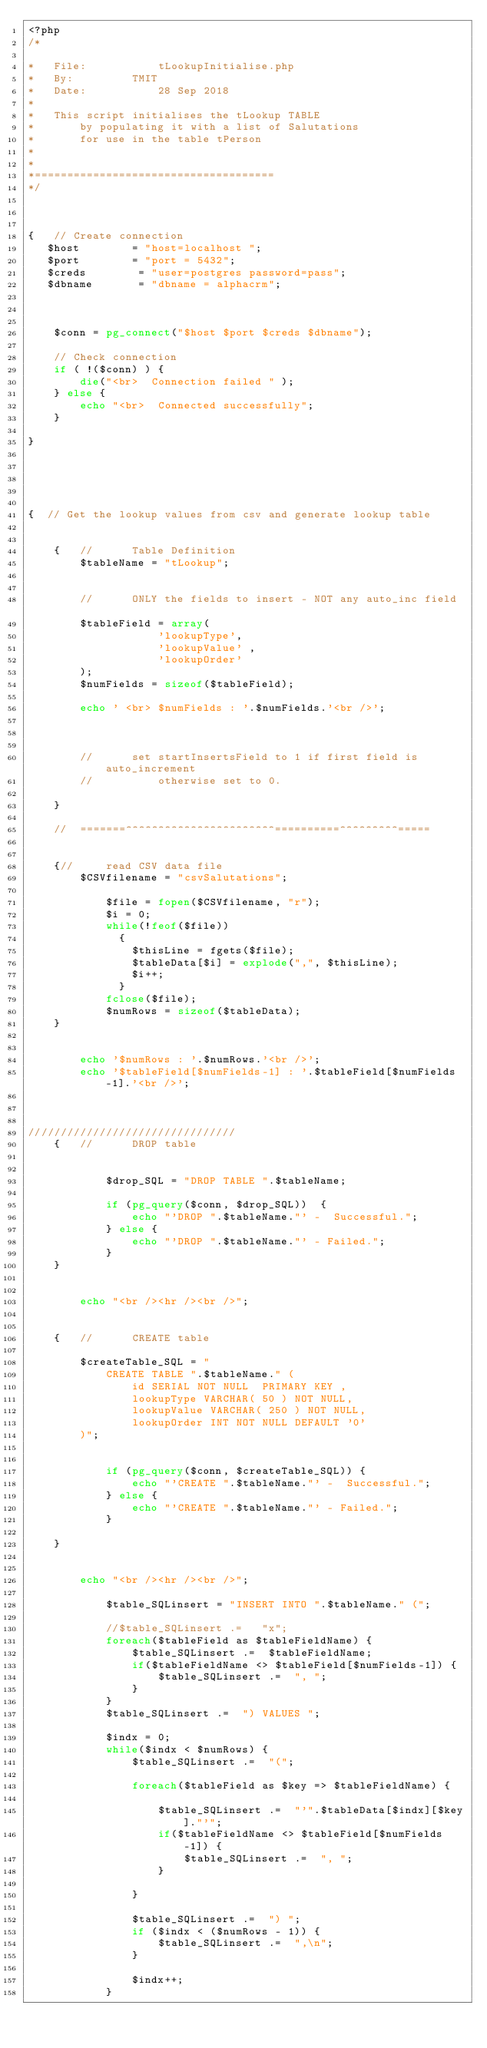<code> <loc_0><loc_0><loc_500><loc_500><_PHP_><?php
/*

*	File:			tLookupInitialise.php
*	By:			TMIT
*	Date:			28 Sep 2018
*
*	This script initialises the tLookup TABLE
*		by populating it with a list of Salutations
*		for use in the table tPerson
*
*
*=====================================
*/



{	// Create connection
   $host        = "host=localhost ";
   $port        = "port = 5432";
   $creds 		 = "user=postgres password=pass";
   $dbname 		 = "dbname = alphacrm";



	$conn = pg_connect("$host $port $creds $dbname");
	
	// Check connection
	if ( !($conn) ) {
	    die("<br>  Connection failed " );
	} else {
		echo "<br>  Connected successfully";
	}
	
}





{  // Get the lookup values from csv and generate lookup table

	
	{	//		Table Definition 
		$tableName = "tLookup";	


		//		ONLY the fields to insert - NOT any auto_inc field	
		$tableField = array(
					'lookupType',
					'lookupValue' ,
					'lookupOrder'
		);
		$numFields = sizeof($tableField);
		
		echo ' <br> $numFields : '.$numFields.'<br />';


			
		//		set startInsertsField to 1 if first field is auto_increment
		//			otherwise set to 0.

	}

	//	=======^^^^^^^^^^^^^^^^^^^^^^^==========^^^^^^^^^=====

										
	{//		read CSV data file
		$CSVfilename = "csvSalutations";	
		
			$file = fopen($CSVfilename, "r"); 		
			$i = 0;
			while(!feof($file))
			  {		  	
				$thisLine = fgets($file);		
				$tableData[$i] = explode(",", $thisLine);
				$i++; 
			  }
			fclose($file);			
			$numRows = sizeof($tableData);
	}
	
	
		echo '$numRows : '.$numRows.'<br />';
		echo '$tableField[$numFields-1] : '.$tableField[$numFields-1].'<br />';



////////////////////////////////
	{	//		DROP table		
	
		
			$drop_SQL = "DROP TABLE ".$tableName;
			
			if (pg_query($conn, $drop_SQL))  {	
				echo "'DROP ".$tableName."' -  Successful.";
			} else {
				echo "'DROP ".$tableName."' - Failed.";
			}
	}
		
		
		echo "<br /><hr /><br />";
	
		
	{	//		CREATE table		
	
		$createTable_SQL = "
			CREATE TABLE ".$tableName." (
				id SERIAL NOT NULL  PRIMARY KEY ,
				lookupType VARCHAR( 50 ) NOT NULL,
				lookupValue VARCHAR( 250 ) NOT NULL, 
				lookupOrder INT NOT NULL DEFAULT '0'
		)";
			
			
			if (pg_query($conn, $createTable_SQL)) {	
				echo "'CREATE ".$tableName."' -  Successful.";
			} else {
				echo "'CREATE ".$tableName."' - Failed.";
			}
			
	}
	
			
		echo "<br /><hr /><br />";
			
			$table_SQLinsert = "INSERT INTO ".$tableName." (";
			
			//$table_SQLinsert .=   "x"; 
			foreach($tableField as $tableFieldName) {
				$table_SQLinsert .=  $tableFieldName;
				if($tableFieldName <> $tableField[$numFields-1]) {
					$table_SQLinsert .=  ", ";
				}
			}
			$table_SQLinsert .=  ") VALUES ";
			
			$indx = 0;				
			while($indx < $numRows) {			
				$table_SQLinsert .=  "(";
				
				foreach($tableField as $key => $tableFieldName) {
					
					$table_SQLinsert .=  "'".$tableData[$indx][$key]."'";
					if($tableFieldName <> $tableField[$numFields-1]) {
						$table_SQLinsert .=  ", ";
					}

				}

				$table_SQLinsert .=  ") ";
				if ($indx < ($numRows - 1)) {
					$table_SQLinsert .=  ",\n";
				}
				
				$indx++;
			}
		</code> 